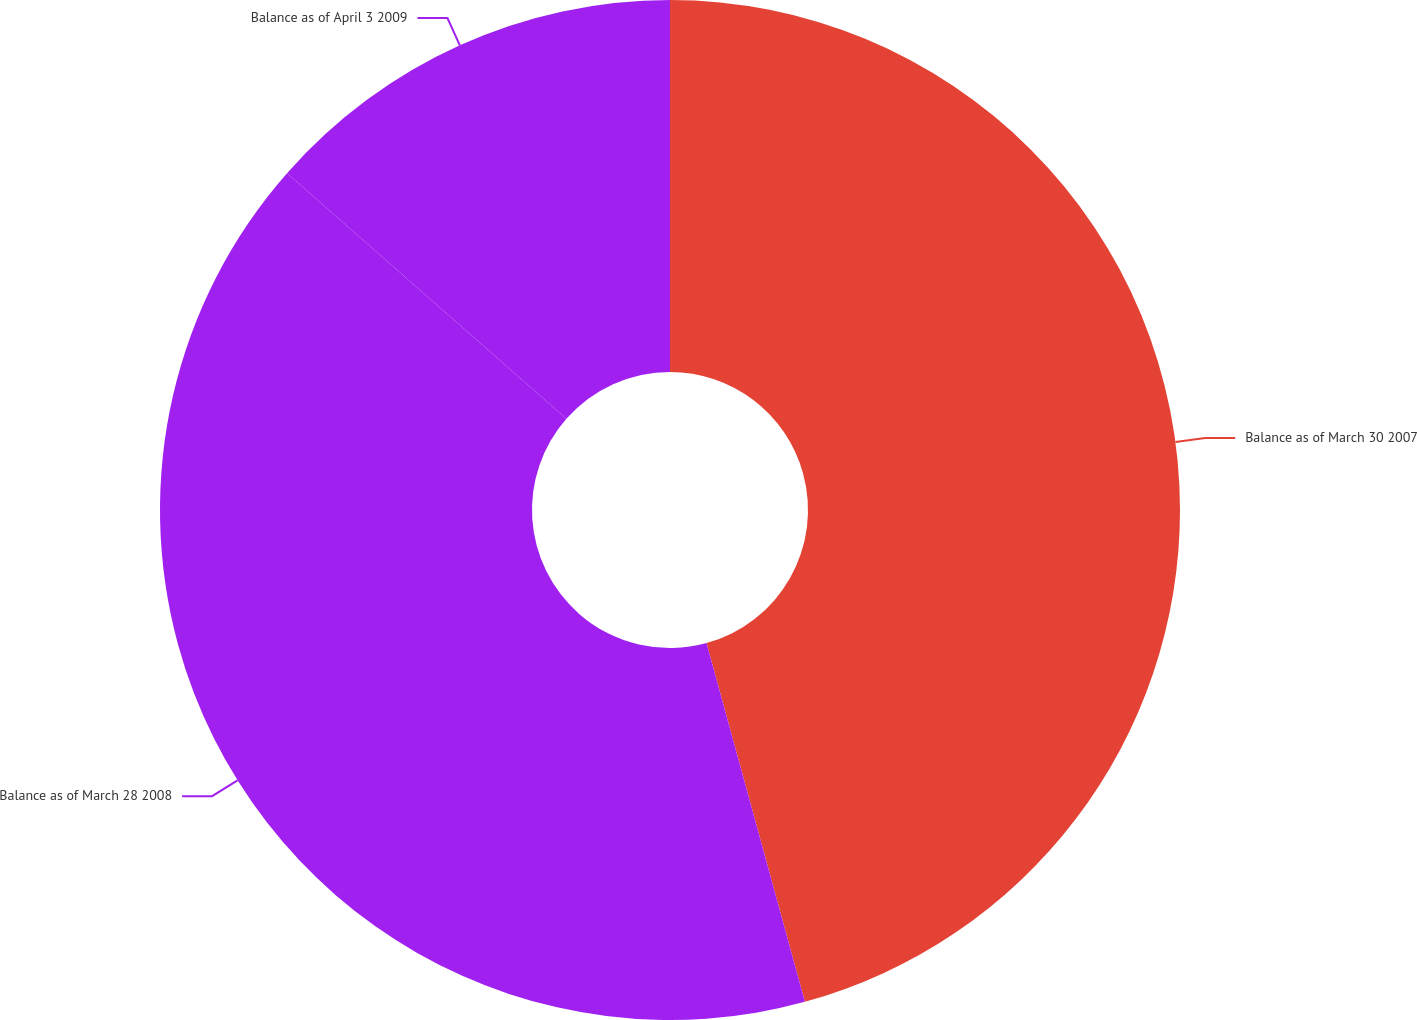Convert chart. <chart><loc_0><loc_0><loc_500><loc_500><pie_chart><fcel>Balance as of March 30 2007<fcel>Balance as of March 28 2008<fcel>Balance as of April 3 2009<nl><fcel>45.74%<fcel>40.74%<fcel>13.52%<nl></chart> 